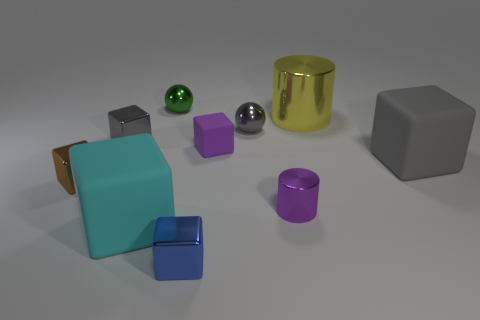Subtract all cyan cylinders. How many gray cubes are left? 2 Subtract all tiny gray shiny blocks. How many blocks are left? 5 Subtract all brown blocks. How many blocks are left? 5 Subtract 2 blocks. How many blocks are left? 4 Subtract all purple cubes. Subtract all yellow cylinders. How many cubes are left? 5 Subtract all spheres. How many objects are left? 8 Subtract all large brown cylinders. Subtract all green things. How many objects are left? 9 Add 6 tiny purple metal cylinders. How many tiny purple metal cylinders are left? 7 Add 3 small blue shiny cubes. How many small blue shiny cubes exist? 4 Subtract 0 blue cylinders. How many objects are left? 10 